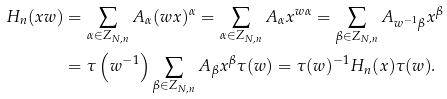<formula> <loc_0><loc_0><loc_500><loc_500>H _ { n } ( x w ) & = \sum _ { \alpha \in Z _ { N , n } } A _ { \alpha } ( w x ) ^ { \alpha } = \sum _ { \alpha \in Z _ { N , n } } A _ { \alpha } x ^ { w \alpha } = \sum _ { \beta \in Z _ { N , n } } A _ { w ^ { - 1 } \beta } x ^ { \beta } \\ & = \tau \left ( w ^ { - 1 } \right ) \sum _ { \beta \in Z _ { N , n } } A _ { \beta } x ^ { \beta } \tau ( w ) = \tau ( w ) ^ { - 1 } H _ { n } ( x ) \tau ( w ) .</formula> 